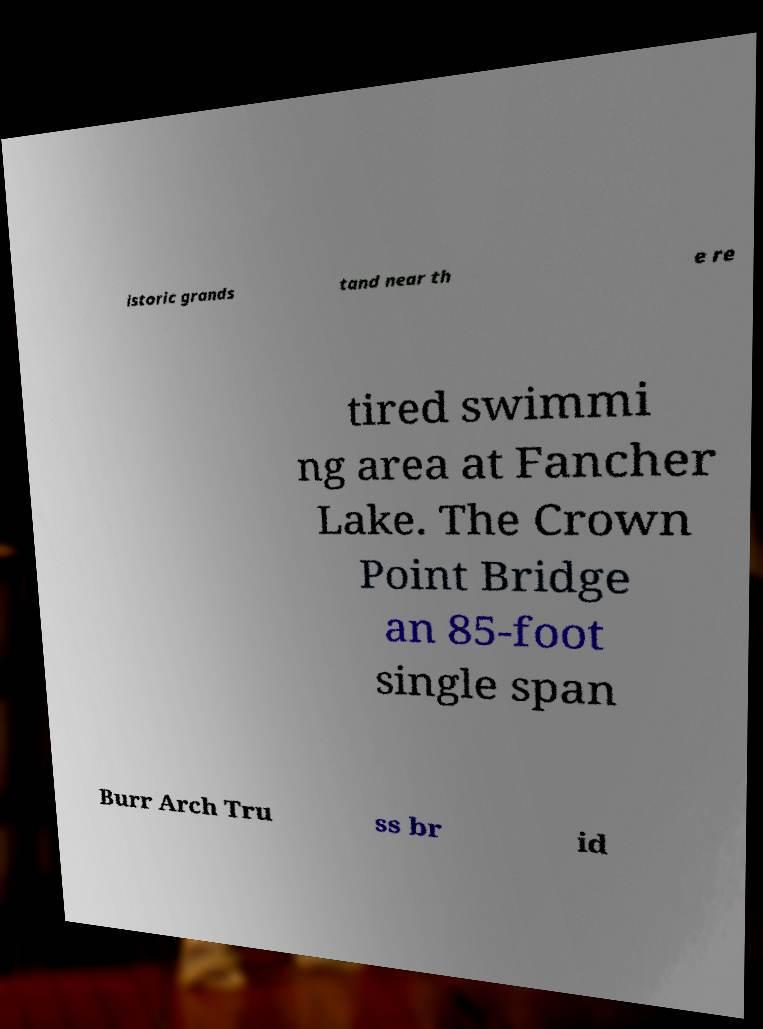Could you assist in decoding the text presented in this image and type it out clearly? istoric grands tand near th e re tired swimmi ng area at Fancher Lake. The Crown Point Bridge an 85-foot single span Burr Arch Tru ss br id 